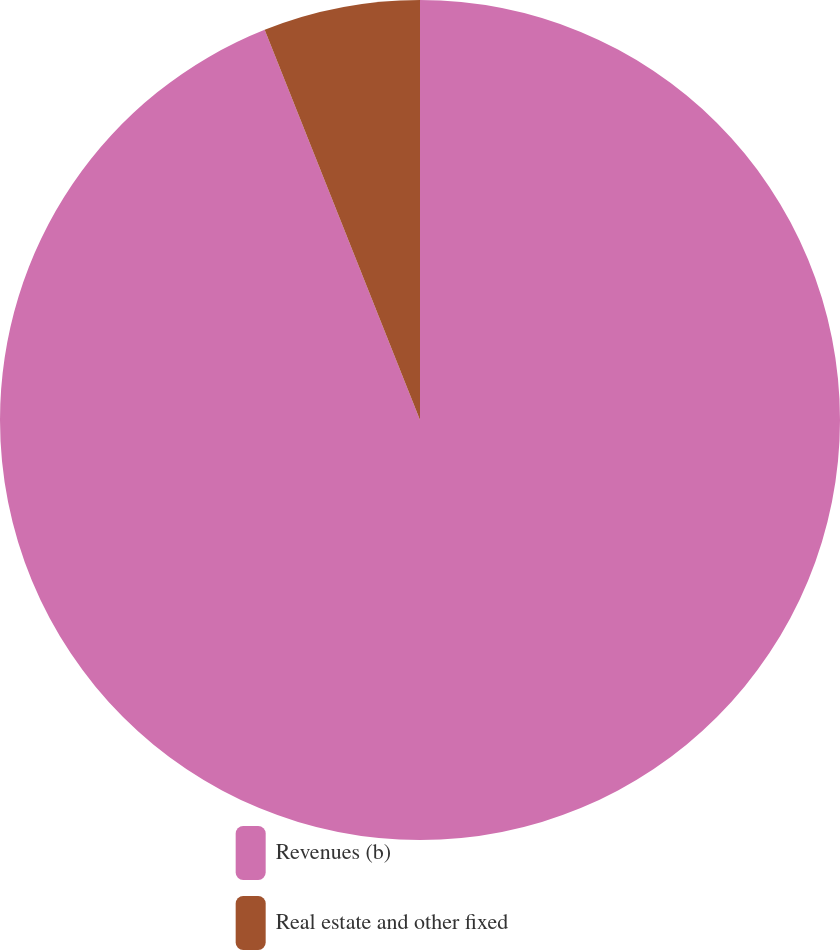<chart> <loc_0><loc_0><loc_500><loc_500><pie_chart><fcel>Revenues (b)<fcel>Real estate and other fixed<nl><fcel>93.97%<fcel>6.03%<nl></chart> 